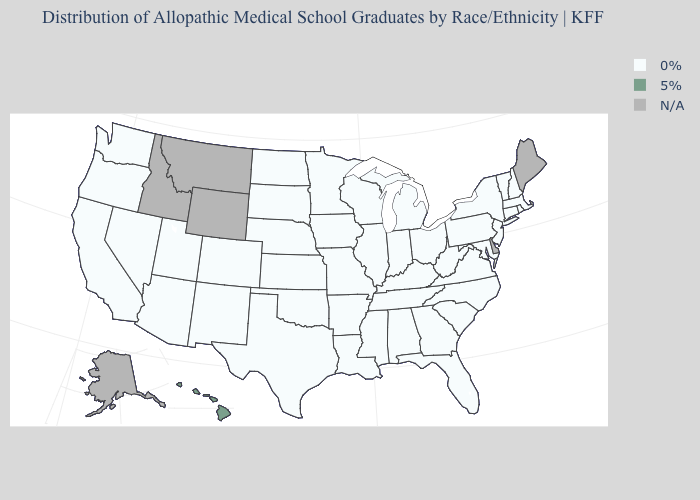How many symbols are there in the legend?
Answer briefly. 3. Among the states that border Tennessee , which have the lowest value?
Short answer required. Alabama, Arkansas, Georgia, Kentucky, Mississippi, Missouri, North Carolina, Virginia. What is the value of Missouri?
Concise answer only. 0%. What is the highest value in the USA?
Give a very brief answer. 5%. Among the states that border Pennsylvania , which have the highest value?
Short answer required. Maryland, New Jersey, New York, Ohio, West Virginia. Name the states that have a value in the range 5%?
Keep it brief. Hawaii. What is the value of Georgia?
Keep it brief. 0%. Name the states that have a value in the range 5%?
Be succinct. Hawaii. What is the lowest value in the USA?
Short answer required. 0%. What is the highest value in states that border Louisiana?
Be succinct. 0%. What is the value of Maryland?
Be succinct. 0%. What is the value of Illinois?
Quick response, please. 0%. What is the value of New Jersey?
Answer briefly. 0%. What is the value of New Mexico?
Quick response, please. 0%. 